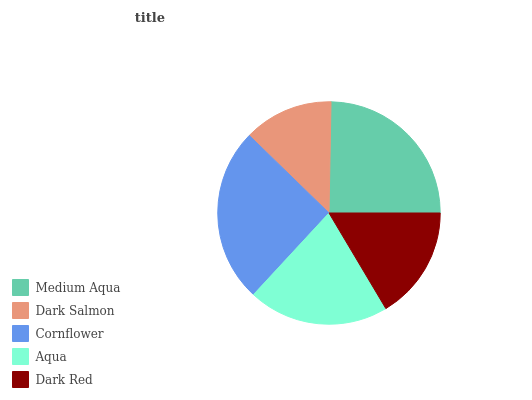Is Dark Salmon the minimum?
Answer yes or no. Yes. Is Cornflower the maximum?
Answer yes or no. Yes. Is Cornflower the minimum?
Answer yes or no. No. Is Dark Salmon the maximum?
Answer yes or no. No. Is Cornflower greater than Dark Salmon?
Answer yes or no. Yes. Is Dark Salmon less than Cornflower?
Answer yes or no. Yes. Is Dark Salmon greater than Cornflower?
Answer yes or no. No. Is Cornflower less than Dark Salmon?
Answer yes or no. No. Is Aqua the high median?
Answer yes or no. Yes. Is Aqua the low median?
Answer yes or no. Yes. Is Cornflower the high median?
Answer yes or no. No. Is Dark Salmon the low median?
Answer yes or no. No. 